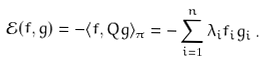<formula> <loc_0><loc_0><loc_500><loc_500>\mathcal { E } ( f , g ) = - \langle f , Q g \rangle _ { \pi } = - \sum _ { i = 1 } ^ { n } \lambda _ { i } f _ { i } g _ { i } \, .</formula> 